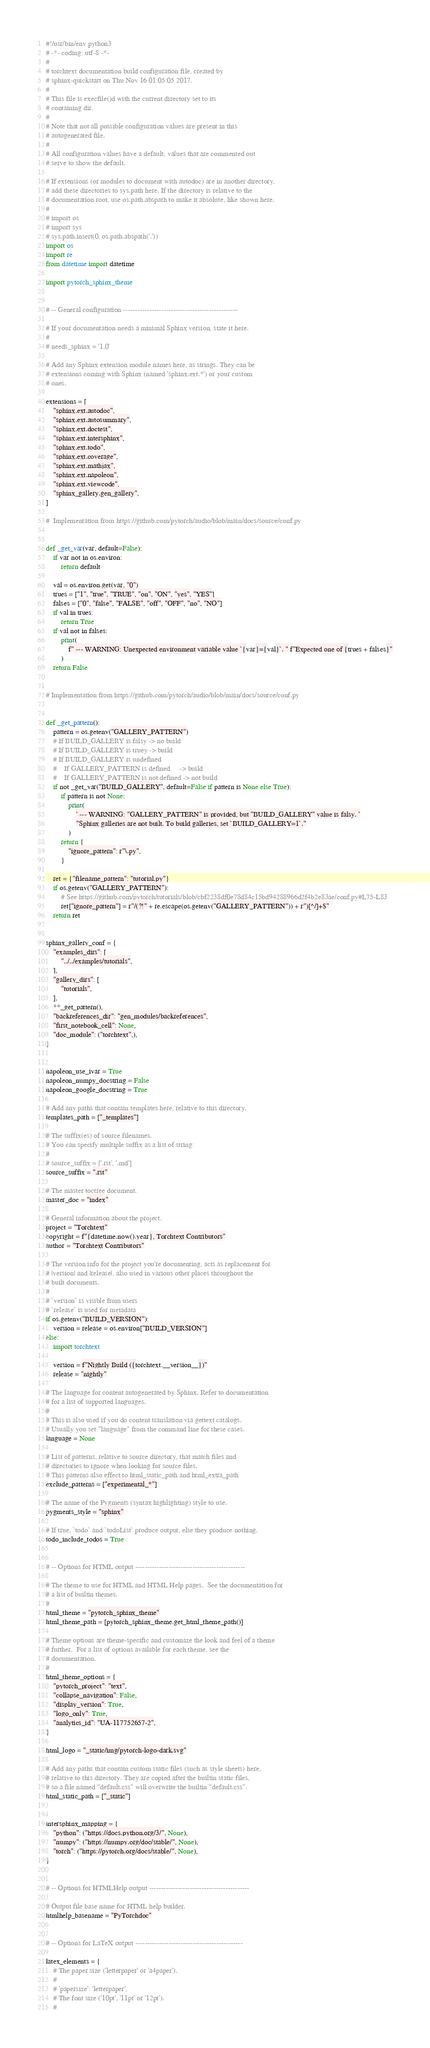Convert code to text. <code><loc_0><loc_0><loc_500><loc_500><_Python_>#!/usr/bin/env python3
# -*- coding: utf-8 -*-
#
# torchtext documentation build configuration file, created by
# sphinx-quickstart on Thu Nov 16 01:05:05 2017.
#
# This file is execfile()d with the current directory set to its
# containing dir.
#
# Note that not all possible configuration values are present in this
# autogenerated file.
#
# All configuration values have a default; values that are commented out
# serve to show the default.

# If extensions (or modules to document with autodoc) are in another directory,
# add these directories to sys.path here. If the directory is relative to the
# documentation root, use os.path.abspath to make it absolute, like shown here.
#
# import os
# import sys
# sys.path.insert(0, os.path.abspath('.'))
import os
import re
from datetime import datetime

import pytorch_sphinx_theme


# -- General configuration ------------------------------------------------

# If your documentation needs a minimal Sphinx version, state it here.
#
# needs_sphinx = '1.0'

# Add any Sphinx extension module names here, as strings. They can be
# extensions coming with Sphinx (named 'sphinx.ext.*') or your custom
# ones.

extensions = [
    "sphinx.ext.autodoc",
    "sphinx.ext.autosummary",
    "sphinx.ext.doctest",
    "sphinx.ext.intersphinx",
    "sphinx.ext.todo",
    "sphinx.ext.coverage",
    "sphinx.ext.mathjax",
    "sphinx.ext.napoleon",
    "sphinx.ext.viewcode",
    "sphinx_gallery.gen_gallery",
]

#  Implementation from https://github.com/pytorch/audio/blob/main/docs/source/conf.py


def _get_var(var, default=False):
    if var not in os.environ:
        return default

    val = os.environ.get(var, "0")
    trues = ["1", "true", "TRUE", "on", "ON", "yes", "YES"]
    falses = ["0", "false", "FALSE", "off", "OFF", "no", "NO"]
    if val in trues:
        return True
    if val not in falses:
        print(
            f" --- WARNING: Unexpected environment variable value `{var}={val}`. " f"Expected one of {trues + falses}"
        )
    return False


# Implementation from https://github.com/pytorch/audio/blob/main/docs/source/conf.py


def _get_pattern():
    pattern = os.getenv("GALLERY_PATTERN")
    # If BUILD_GALLERY is falsy -> no build
    # If BUILD_GALLERY is truey -> build
    # If BUILD_GALLERY is undefined
    #    If GALLERY_PATTERN is defined     -> build
    #    If GALLERY_PATTERN is not defined -> not build
    if not _get_var("BUILD_GALLERY", default=False if pattern is None else True):
        if pattern is not None:
            print(
                ' --- WARNING: "GALLERY_PATTERN" is provided, but "BUILD_GALLERY" value is falsy. '
                "Sphinx galleries are not built. To build galleries, set `BUILD_GALLERY=1`."
            )
        return {
            "ignore_pattern": r"\.py",
        }

    ret = {"filename_pattern": "tutorial.py"}
    if os.getenv("GALLERY_PATTERN"):
        # See https://github.com/pytorch/tutorials/blob/cbf2238df0e78d84c15bd94288966d2f4b2e83ae/conf.py#L75-L83
        ret["ignore_pattern"] = r"/(?!" + re.escape(os.getenv("GALLERY_PATTERN")) + r")[^/]+$"
    return ret


sphinx_gallery_conf = {
    "examples_dirs": [
        "../../examples/tutorials",
    ],
    "gallery_dirs": [
        "tutorials",
    ],
    **_get_pattern(),
    "backreferences_dir": "gen_modules/backreferences",
    "first_notebook_cell": None,
    "doc_module": ("torchtext",),
}


napoleon_use_ivar = True
napoleon_numpy_docstring = False
napoleon_google_docstring = True

# Add any paths that contain templates here, relative to this directory.
templates_path = ["_templates"]

# The suffix(es) of source filenames.
# You can specify multiple suffix as a list of string:
#
# source_suffix = ['.rst', '.md']
source_suffix = ".rst"

# The master toctree document.
master_doc = "index"

# General information about the project.
project = "Torchtext"
copyright = f"{datetime.now().year}, Torchtext Contributors"
author = "Torchtext Contributors"

# The version info for the project you're documenting, acts as replacement for
# |version| and |release|, also used in various other places throughout the
# built documents.
#
# `version` is visible from users
# `release` is used for metadata
if os.getenv("BUILD_VERSION"):
    version = release = os.environ["BUILD_VERSION"]
else:
    import torchtext

    version = f"Nightly Build ({torchtext.__version__})"
    release = "nightly"

# The language for content autogenerated by Sphinx. Refer to documentation
# for a list of supported languages.
#
# This is also used if you do content translation via gettext catalogs.
# Usually you set "language" from the command line for these cases.
language = None

# List of patterns, relative to source directory, that match files and
# directories to ignore when looking for source files.
# This patterns also effect to html_static_path and html_extra_path
exclude_patterns = ["experimental_*"]

# The name of the Pygments (syntax highlighting) style to use.
pygments_style = "sphinx"

# If true, `todo` and `todoList` produce output, else they produce nothing.
todo_include_todos = True


# -- Options for HTML output ----------------------------------------------

# The theme to use for HTML and HTML Help pages.  See the documentation for
# a list of builtin themes.
#
html_theme = "pytorch_sphinx_theme"
html_theme_path = [pytorch_sphinx_theme.get_html_theme_path()]

# Theme options are theme-specific and customize the look and feel of a theme
# further.  For a list of options available for each theme, see the
# documentation.
#
html_theme_options = {
    "pytorch_project": "text",
    "collapse_navigation": False,
    "display_version": True,
    "logo_only": True,
    "analytics_id": "UA-117752657-2",
}

html_logo = "_static/img/pytorch-logo-dark.svg"

# Add any paths that contain custom static files (such as style sheets) here,
# relative to this directory. They are copied after the builtin static files,
# so a file named "default.css" will overwrite the builtin "default.css".
html_static_path = ["_static"]


intersphinx_mapping = {
    "python": ("https://docs.python.org/3/", None),
    "numpy": ("https://numpy.org/doc/stable/", None),
    "torch": ("https://pytorch.org/docs/stable/", None),
}


# -- Options for HTMLHelp output ------------------------------------------

# Output file base name for HTML help builder.
htmlhelp_basename = "PyTorchdoc"


# -- Options for LaTeX output ---------------------------------------------

latex_elements = {
    # The paper size ('letterpaper' or 'a4paper').
    #
    # 'papersize': 'letterpaper',
    # The font size ('10pt', '11pt' or '12pt').
    #</code> 